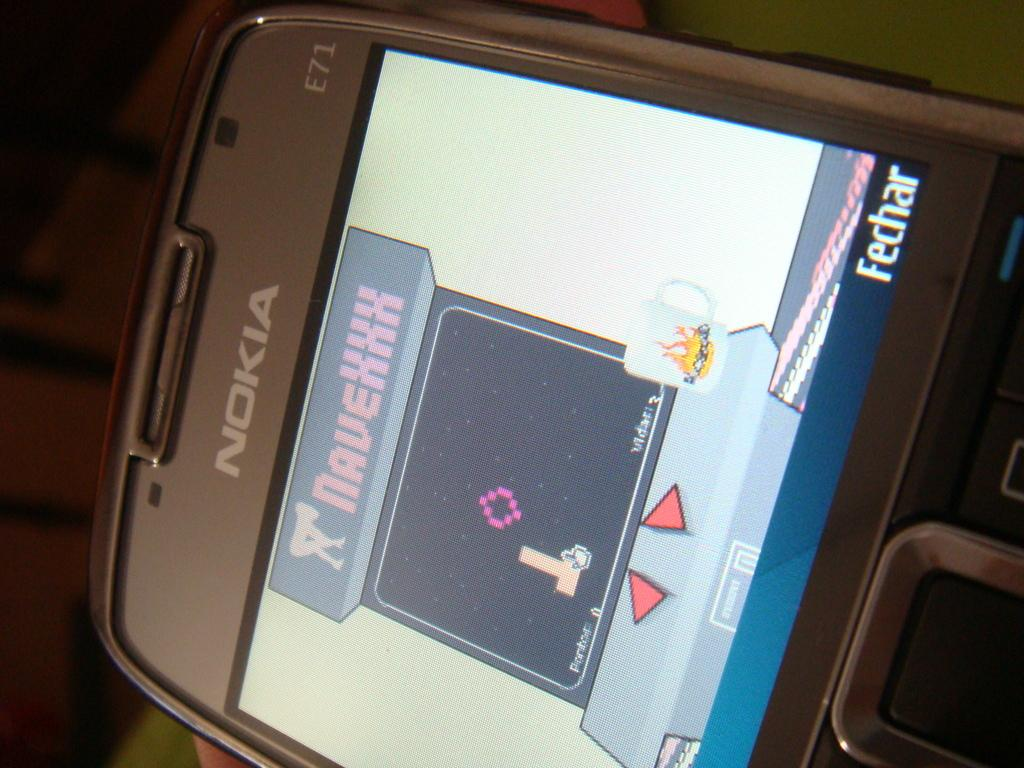<image>
Give a short and clear explanation of the subsequent image. a Nokia phone with some images on it 